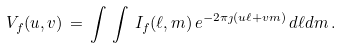Convert formula to latex. <formula><loc_0><loc_0><loc_500><loc_500>V _ { f } ( u , v ) \, = \, \int \, \int \, I _ { f } ( \ell , m ) \, e ^ { - 2 \pi \jmath ( u \ell + v m ) } \, d \ell d m \, .</formula> 